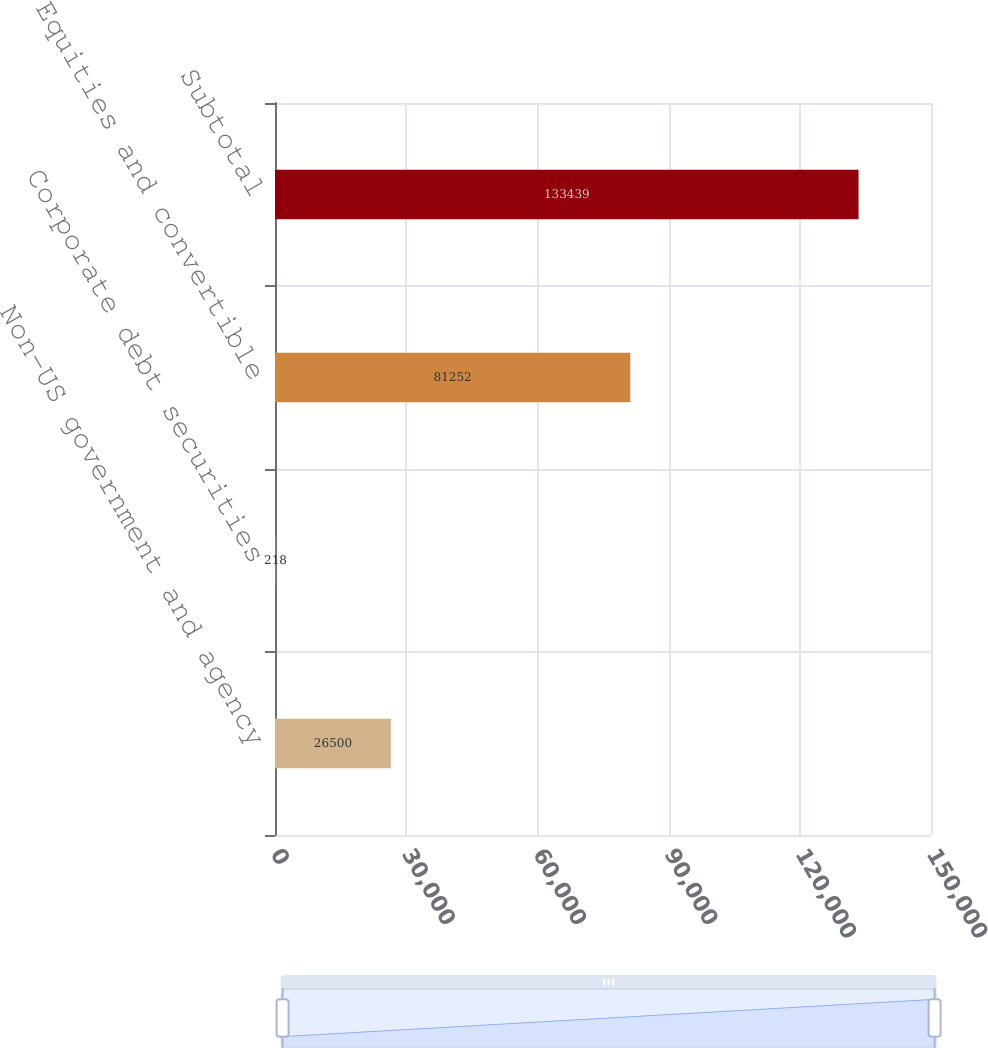<chart> <loc_0><loc_0><loc_500><loc_500><bar_chart><fcel>Non-US government and agency<fcel>Corporate debt securities<fcel>Equities and convertible<fcel>Subtotal<nl><fcel>26500<fcel>218<fcel>81252<fcel>133439<nl></chart> 